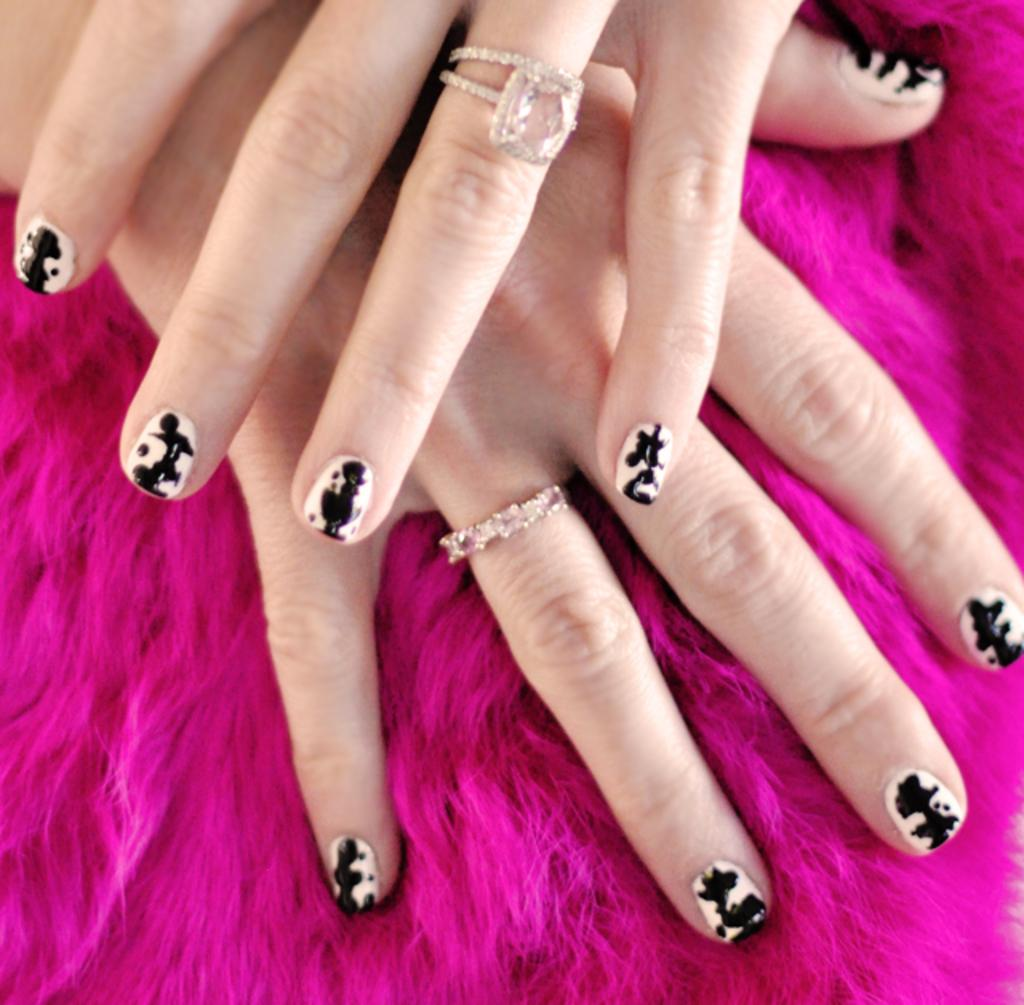How many people are in the image? There are two women in the image. What are the women doing in the image? Their hands are touching, with one hand on top of the other. What is the color of the surface they are on? They are on a pink color fur surface. What type of jewelry can be seen on their fingers? Finger rings are visible on their fingers. What type of mailbox can be seen in the image? There is no mailbox present in the image. What are the women using to poke the sticks in the image? There are no sticks present in the image. 